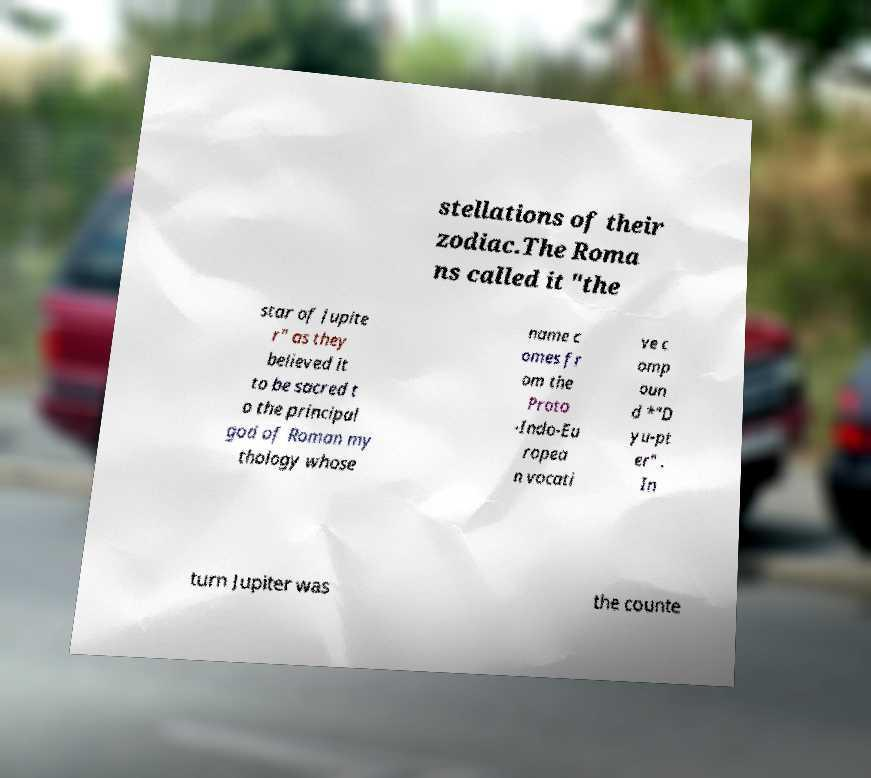Please read and relay the text visible in this image. What does it say? stellations of their zodiac.The Roma ns called it "the star of Jupite r" as they believed it to be sacred t o the principal god of Roman my thology whose name c omes fr om the Proto -Indo-Eu ropea n vocati ve c omp oun d *"D yu-pt er" . In turn Jupiter was the counte 